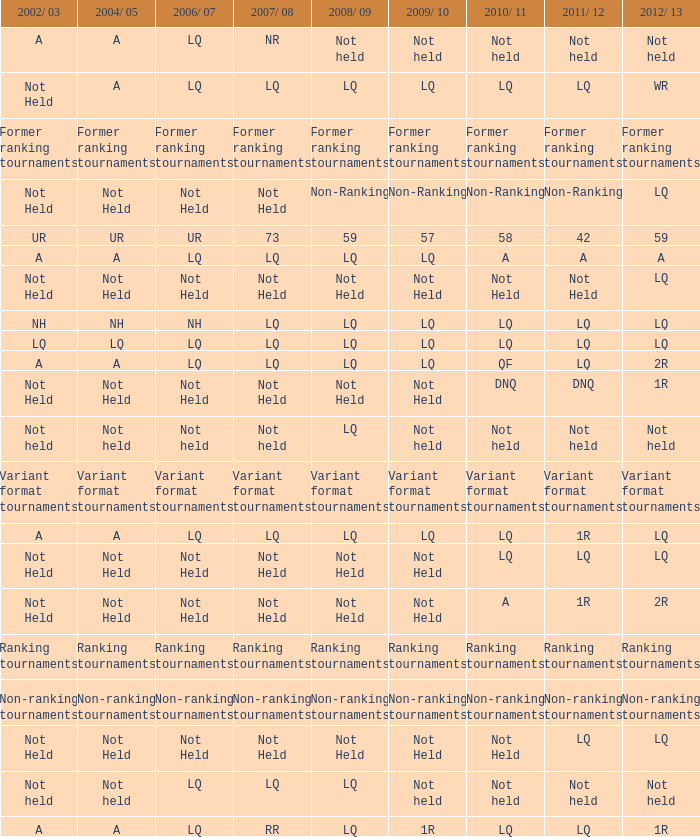Name the 2011/12 with 2008/09 of not held with 2010/11 of not held LQ, Not Held, Not held. 